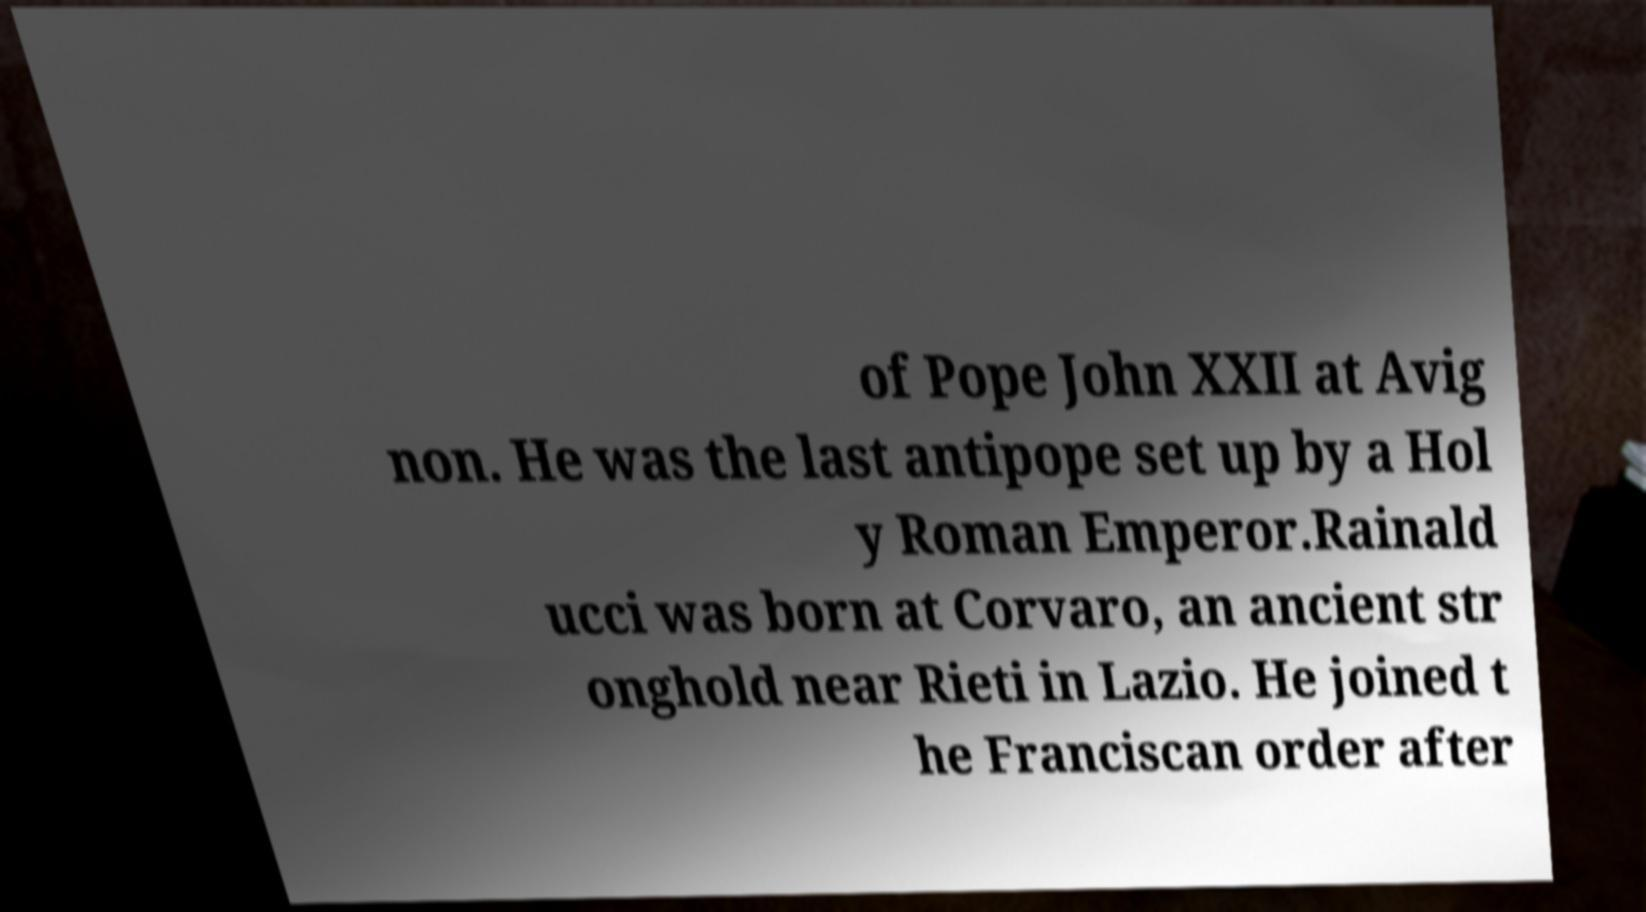There's text embedded in this image that I need extracted. Can you transcribe it verbatim? of Pope John XXII at Avig non. He was the last antipope set up by a Hol y Roman Emperor.Rainald ucci was born at Corvaro, an ancient str onghold near Rieti in Lazio. He joined t he Franciscan order after 